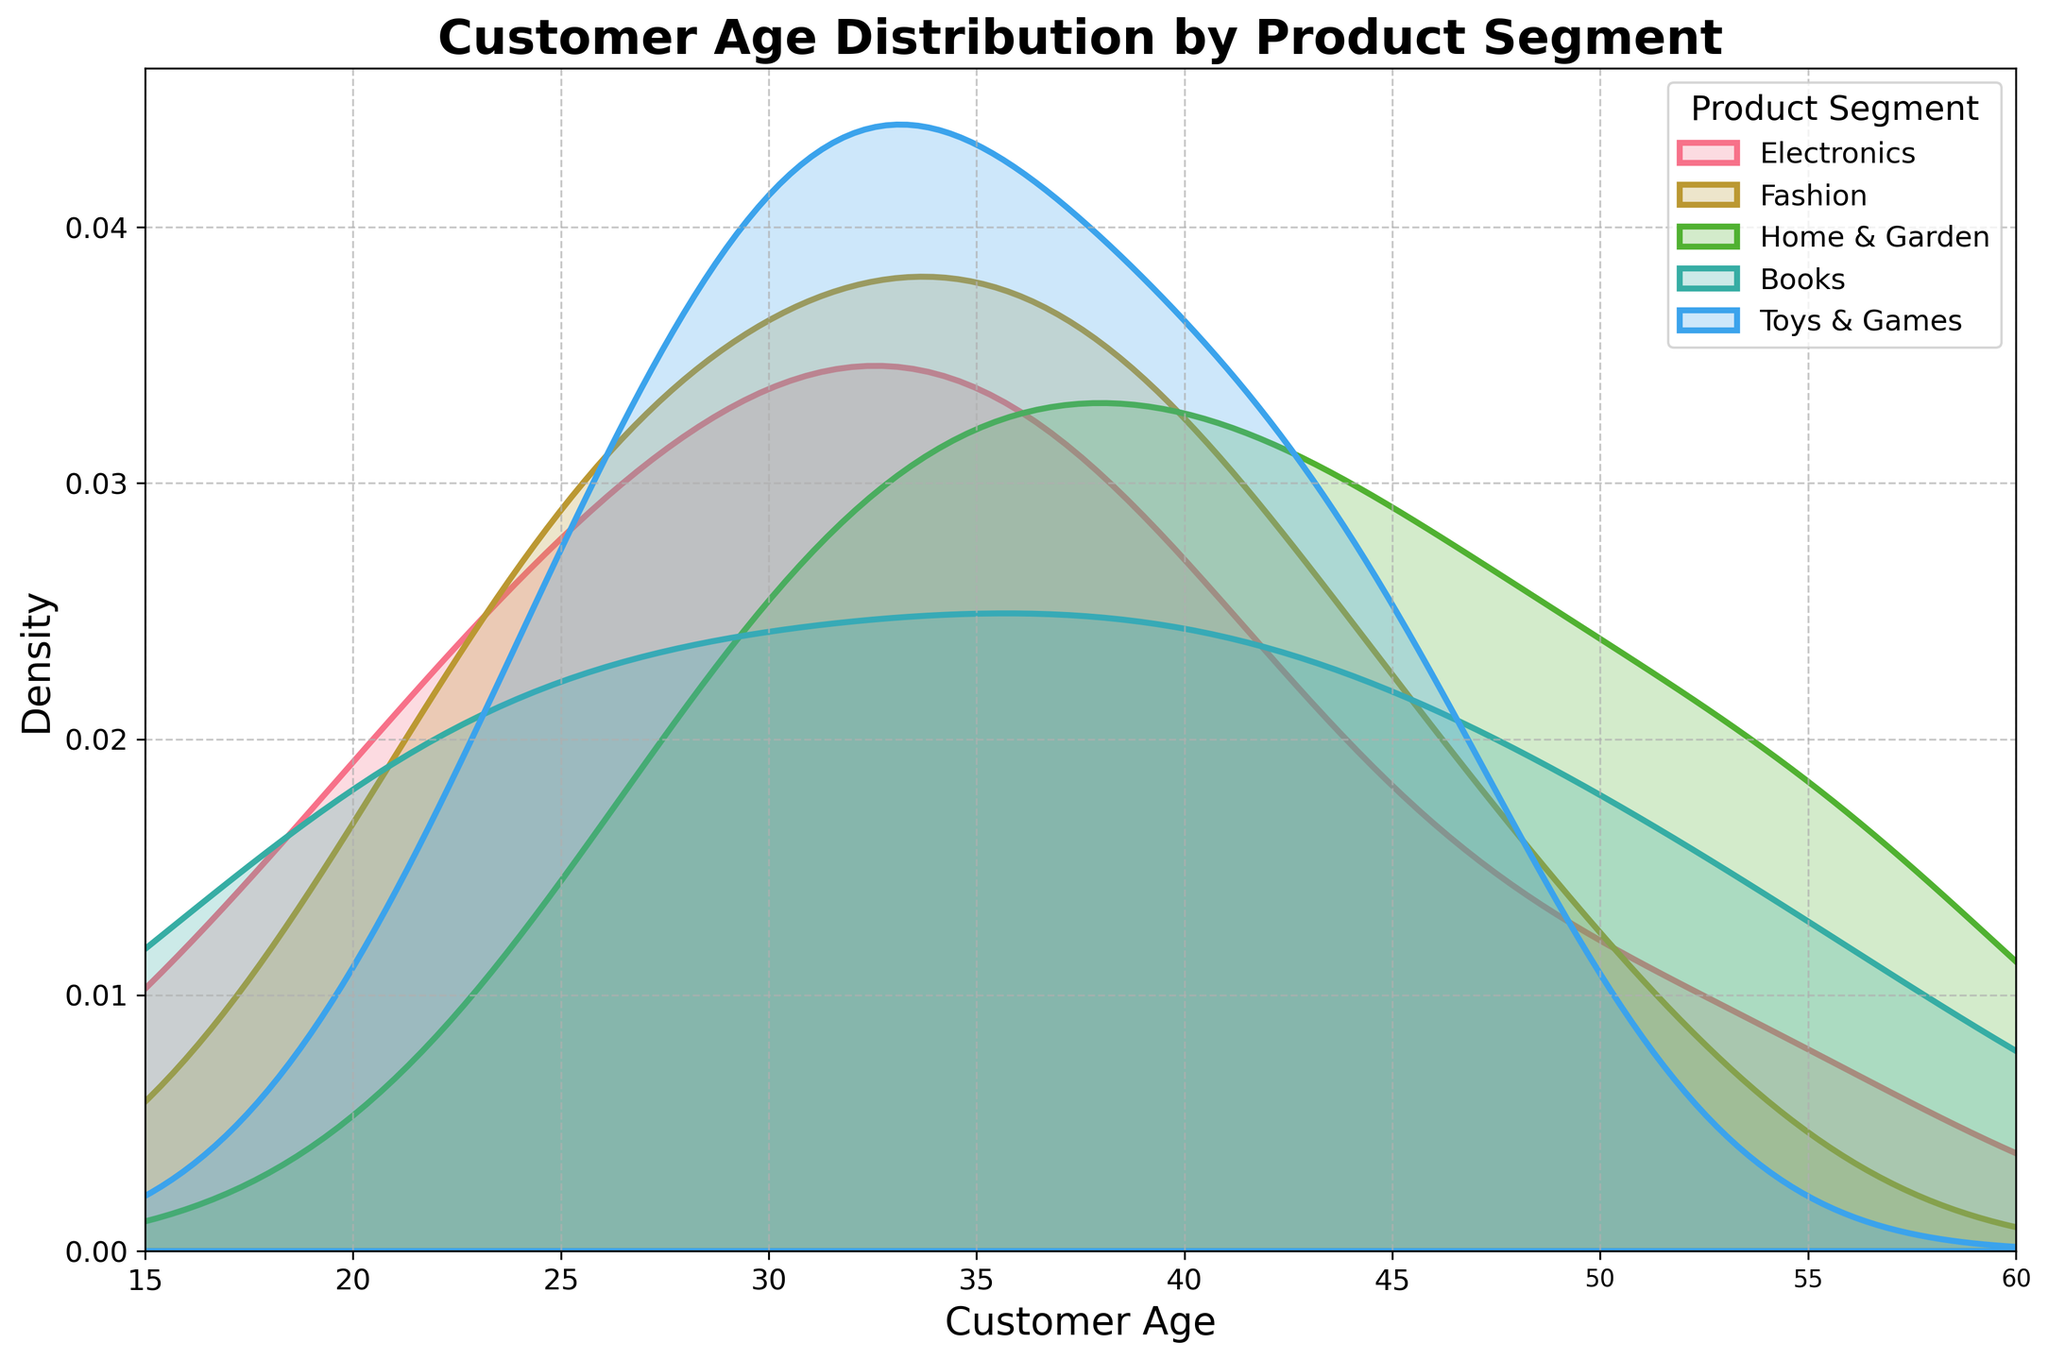Which product segment includes customers of age 52? By checking the density plot, we can look for peaks or indicated points around age 52. If there are multiple segments, all applicable segments need to be considered.
Answer: Electronics, Home & Garden What is the range of ages covered in the Fashion segment? Look at the density curve labeled "Fashion" and identify the starting and ending points on the x-axis.
Answer: 22 to 48 Which product segment has the most concentrated customer age group? Identify the densest peak among the various density plots. The segment with the tallest, most narrow peak is the most concentrated.
Answer: Home & Garden Which product segment has the widest age distribution? Look for the density curve that spans the largest part of the x-axis, from the lowest to highest age.
Answer: Books Are there any product segments that attract customer ages centered around 30? Look for segments whose density plots have a significant peak near the age of 30 on the x-axis.
Answer: Home & Garden, Fashion, Toys & Games Which segment's density plot indicates that it appeals to very young (below 20) and very old (above 50) customers alike? Check the density plots for peaks at both low (below 20) and high (above 50) age ranges.
Answer: Books Do any segments have overlapping customer age groups? Observe if two or more density plots intersect or align closely within certain age ranges.
Answer: Yes, several segments have overlapping age groups, e.g., Electronics and Toys & Games, in the 30s age range Which age group is least represented across all product segments? Look at the x-axis range and identify the parts where density is nearly zero across all plots.
Answer: Around 20-22 What's the approximate peak density value for the Electronics segment? Identify the highest point of the Electronics segment curve on the y-axis.
Answer: Approximately 0.06 Which two product segments have the least overlap in their customer ages? Identify density plots that are the furthest apart in terms of overlap on the x-axis.
Answer: Fashion and Books 